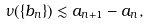Convert formula to latex. <formula><loc_0><loc_0><loc_500><loc_500>\nu ( \{ b _ { n } \} ) \lesssim a _ { n + 1 } - a _ { n } ,</formula> 